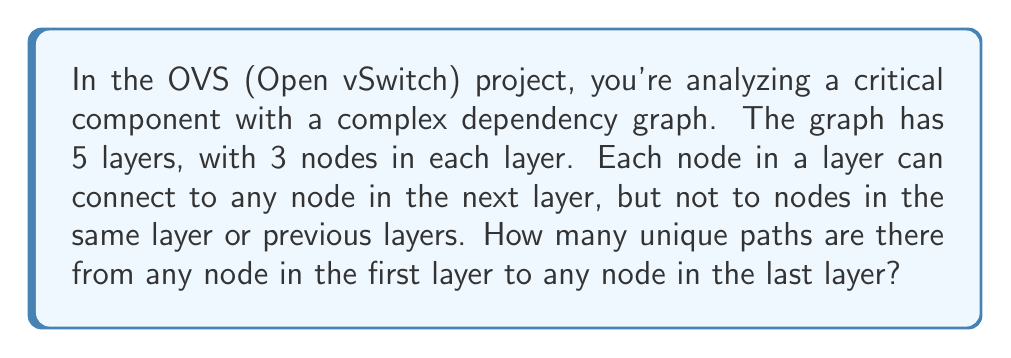Help me with this question. Let's approach this step-by-step:

1) First, let's understand what the question is asking:
   - We have 5 layers in the dependency graph
   - Each layer has 3 nodes
   - Connections only go from one layer to the next

2) This problem can be solved using the multiplication principle of combinatorics.

3) For each step in the path:
   - We have 3 choices (the 3 nodes in the next layer)
   - We make this choice 4 times (to move through all 5 layers)

4) The total number of paths is therefore:

   $$ 3 \times 3 \times 3 \times 3 = 3^4 $$

5) We can also express this as:

   $$ 3^{(5-1)} = 3^4 $$

   Where 5 is the number of layers, and we subtract 1 because we make 4 choices to move through 5 layers.

6) Calculating this:

   $$ 3^4 = 3 \times 3 \times 3 \times 3 = 81 $$

7) Note that this is the number of paths from any single node in the first layer to any node in the last layer. If we wanted the total number of paths from all nodes in the first layer to all nodes in the last layer, we would multiply by 3 (for the starting nodes) and 3 (for the ending nodes), giving $3 \times 81 \times 3 = 729$.
Answer: 81 